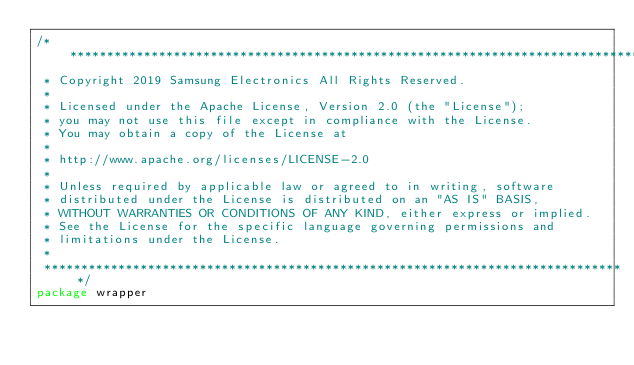<code> <loc_0><loc_0><loc_500><loc_500><_Go_>/*******************************************************************************
 * Copyright 2019 Samsung Electronics All Rights Reserved.
 *
 * Licensed under the Apache License, Version 2.0 (the "License");
 * you may not use this file except in compliance with the License.
 * You may obtain a copy of the License at
 *
 * http://www.apache.org/licenses/LICENSE-2.0
 *
 * Unless required by applicable law or agreed to in writing, software
 * distributed under the License is distributed on an "AS IS" BASIS,
 * WITHOUT WARRANTIES OR CONDITIONS OF ANY KIND, either express or implied.
 * See the License for the specific language governing permissions and
 * limitations under the License.
 *
 *******************************************************************************/
package wrapper
</code> 